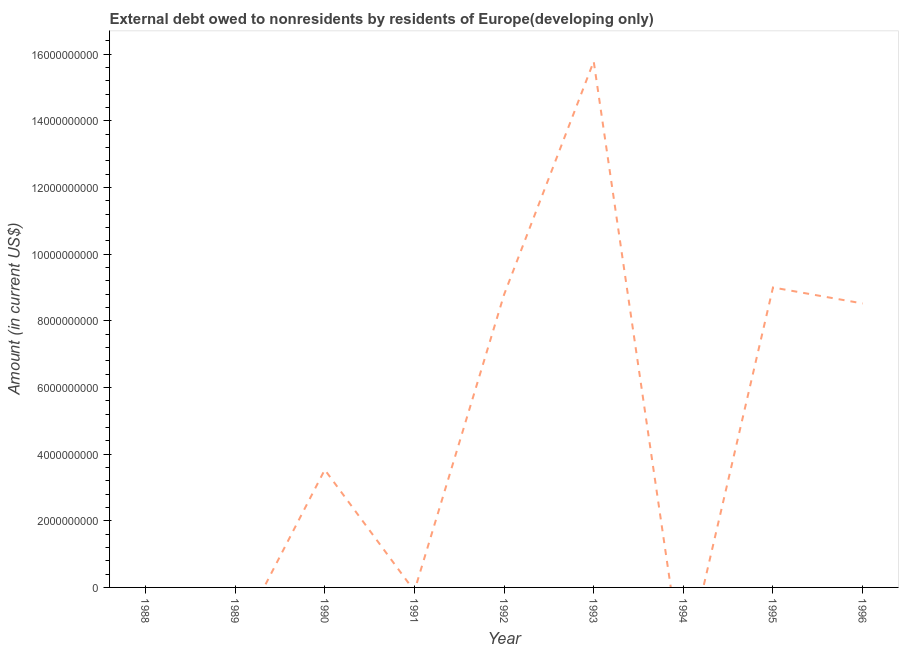What is the debt in 1991?
Ensure brevity in your answer.  0. Across all years, what is the maximum debt?
Your response must be concise. 1.58e+1. What is the sum of the debt?
Give a very brief answer. 4.56e+1. What is the difference between the debt in 1990 and 1995?
Provide a succinct answer. -5.47e+09. What is the average debt per year?
Offer a very short reply. 5.07e+09. What is the median debt?
Your answer should be compact. 3.53e+09. Is the debt in 1990 less than that in 1993?
Give a very brief answer. Yes. What is the difference between the highest and the second highest debt?
Ensure brevity in your answer.  6.78e+09. Is the sum of the debt in 1992 and 1993 greater than the maximum debt across all years?
Keep it short and to the point. Yes. What is the difference between the highest and the lowest debt?
Provide a succinct answer. 1.58e+1. In how many years, is the debt greater than the average debt taken over all years?
Provide a succinct answer. 4. How many years are there in the graph?
Your response must be concise. 9. What is the difference between two consecutive major ticks on the Y-axis?
Keep it short and to the point. 2.00e+09. What is the title of the graph?
Offer a very short reply. External debt owed to nonresidents by residents of Europe(developing only). What is the label or title of the Y-axis?
Your response must be concise. Amount (in current US$). What is the Amount (in current US$) of 1989?
Offer a very short reply. 0. What is the Amount (in current US$) in 1990?
Your answer should be very brief. 3.53e+09. What is the Amount (in current US$) of 1992?
Make the answer very short. 8.78e+09. What is the Amount (in current US$) of 1993?
Make the answer very short. 1.58e+1. What is the Amount (in current US$) in 1994?
Make the answer very short. 0. What is the Amount (in current US$) in 1995?
Provide a succinct answer. 9.00e+09. What is the Amount (in current US$) of 1996?
Offer a very short reply. 8.52e+09. What is the difference between the Amount (in current US$) in 1990 and 1992?
Give a very brief answer. -5.25e+09. What is the difference between the Amount (in current US$) in 1990 and 1993?
Offer a very short reply. -1.23e+1. What is the difference between the Amount (in current US$) in 1990 and 1995?
Provide a succinct answer. -5.47e+09. What is the difference between the Amount (in current US$) in 1990 and 1996?
Give a very brief answer. -4.99e+09. What is the difference between the Amount (in current US$) in 1992 and 1993?
Your response must be concise. -7.00e+09. What is the difference between the Amount (in current US$) in 1992 and 1995?
Keep it short and to the point. -2.16e+08. What is the difference between the Amount (in current US$) in 1992 and 1996?
Your answer should be compact. 2.64e+08. What is the difference between the Amount (in current US$) in 1993 and 1995?
Your answer should be very brief. 6.78e+09. What is the difference between the Amount (in current US$) in 1993 and 1996?
Your response must be concise. 7.26e+09. What is the difference between the Amount (in current US$) in 1995 and 1996?
Keep it short and to the point. 4.80e+08. What is the ratio of the Amount (in current US$) in 1990 to that in 1992?
Your response must be concise. 0.4. What is the ratio of the Amount (in current US$) in 1990 to that in 1993?
Ensure brevity in your answer.  0.22. What is the ratio of the Amount (in current US$) in 1990 to that in 1995?
Give a very brief answer. 0.39. What is the ratio of the Amount (in current US$) in 1990 to that in 1996?
Make the answer very short. 0.41. What is the ratio of the Amount (in current US$) in 1992 to that in 1993?
Your answer should be compact. 0.56. What is the ratio of the Amount (in current US$) in 1992 to that in 1995?
Give a very brief answer. 0.98. What is the ratio of the Amount (in current US$) in 1992 to that in 1996?
Make the answer very short. 1.03. What is the ratio of the Amount (in current US$) in 1993 to that in 1995?
Your response must be concise. 1.75. What is the ratio of the Amount (in current US$) in 1993 to that in 1996?
Offer a very short reply. 1.85. What is the ratio of the Amount (in current US$) in 1995 to that in 1996?
Ensure brevity in your answer.  1.06. 